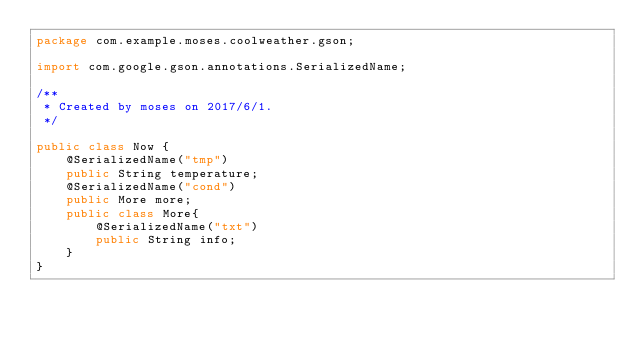Convert code to text. <code><loc_0><loc_0><loc_500><loc_500><_Java_>package com.example.moses.coolweather.gson;

import com.google.gson.annotations.SerializedName;

/**
 * Created by moses on 2017/6/1.
 */

public class Now {
    @SerializedName("tmp")
    public String temperature;
    @SerializedName("cond")
    public More more;
    public class More{
        @SerializedName("txt")
        public String info;
    }
}
</code> 